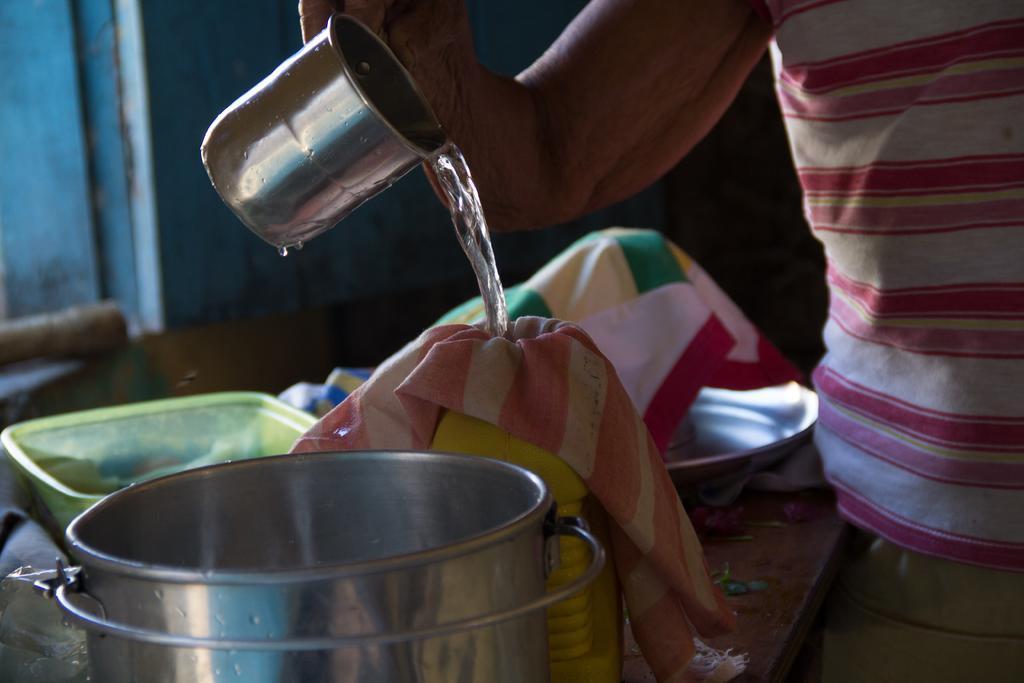How would you summarize this image in a sentence or two? In this image I can see a person holding a glass in hand. I can see a table and on it I can see a yellow colored can and few metal containers. I can see the blue and black colored background. 